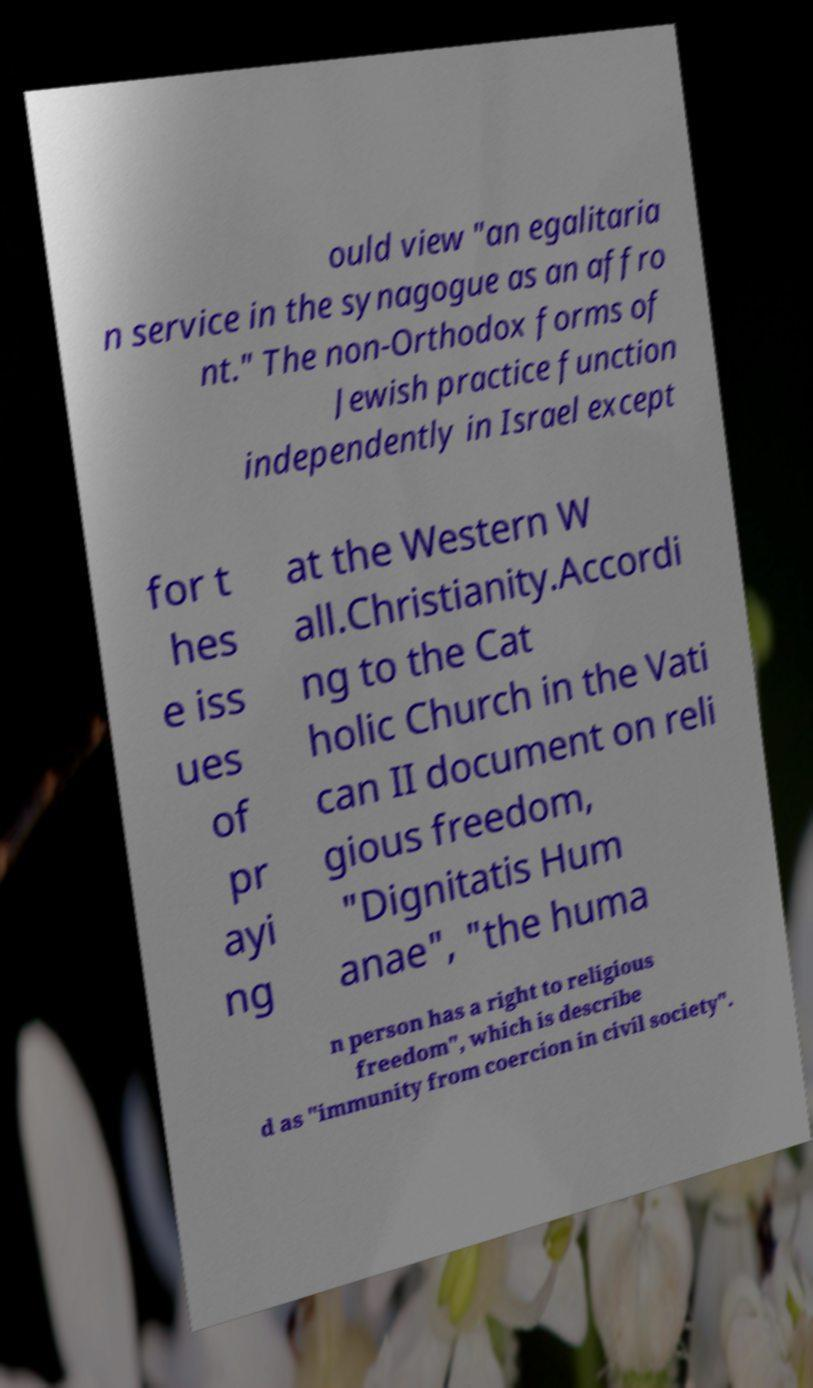There's text embedded in this image that I need extracted. Can you transcribe it verbatim? ould view "an egalitaria n service in the synagogue as an affro nt." The non-Orthodox forms of Jewish practice function independently in Israel except for t hes e iss ues of pr ayi ng at the Western W all.Christianity.Accordi ng to the Cat holic Church in the Vati can II document on reli gious freedom, "Dignitatis Hum anae", "the huma n person has a right to religious freedom", which is describe d as "immunity from coercion in civil society". 